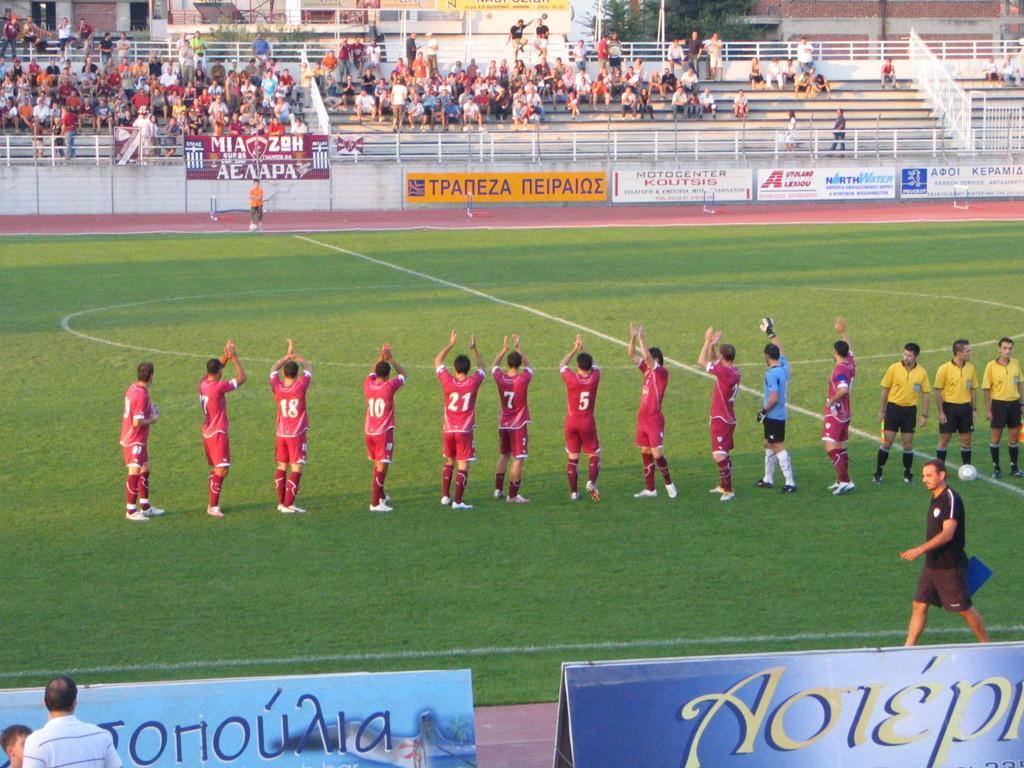Describe this image in one or two sentences. In this image in the foreground there are boards. There is grass. There are people standing on the ground. There is a wall. There are people sitting on the steps in the background. There are houses. 